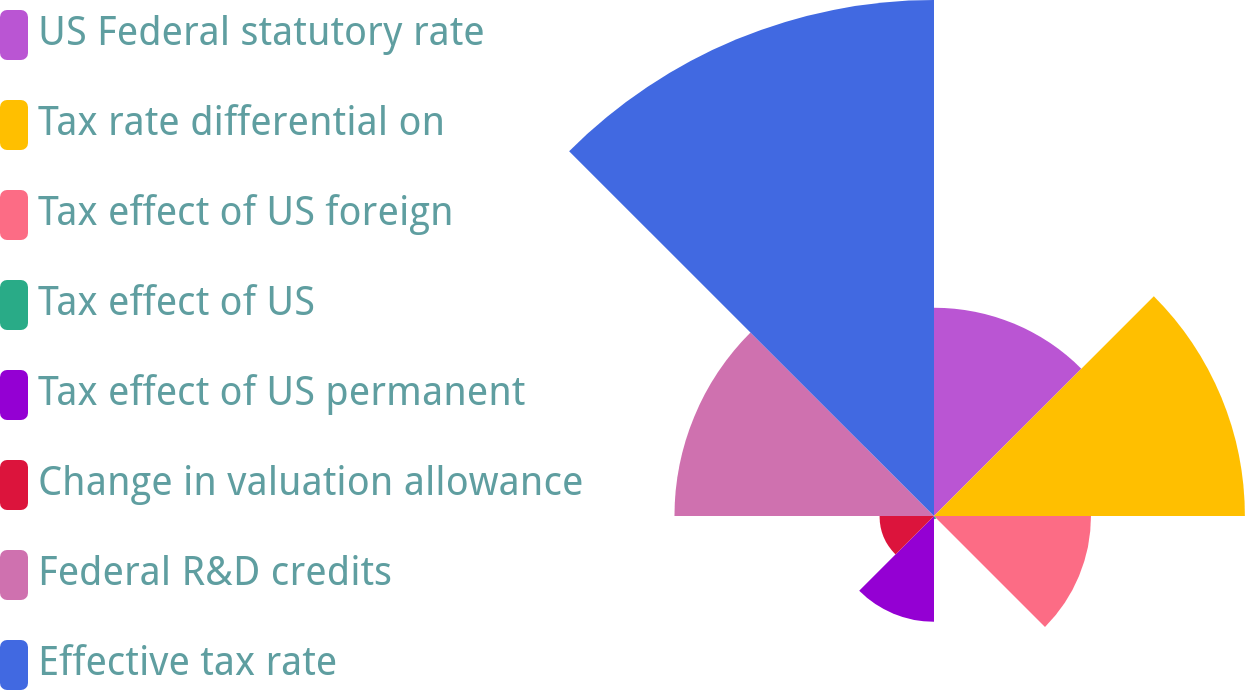Convert chart to OTSL. <chart><loc_0><loc_0><loc_500><loc_500><pie_chart><fcel>US Federal statutory rate<fcel>Tax rate differential on<fcel>Tax effect of US foreign<fcel>Tax effect of US<fcel>Tax effect of US permanent<fcel>Change in valuation allowance<fcel>Federal R&D credits<fcel>Effective tax rate<nl><fcel>12.9%<fcel>19.25%<fcel>9.72%<fcel>0.2%<fcel>6.55%<fcel>3.37%<fcel>16.07%<fcel>31.95%<nl></chart> 